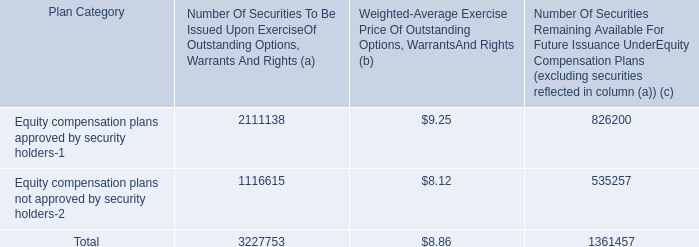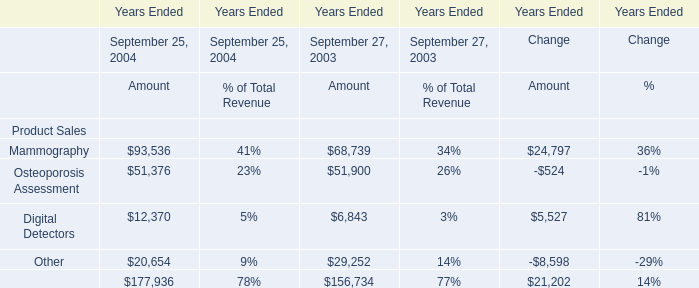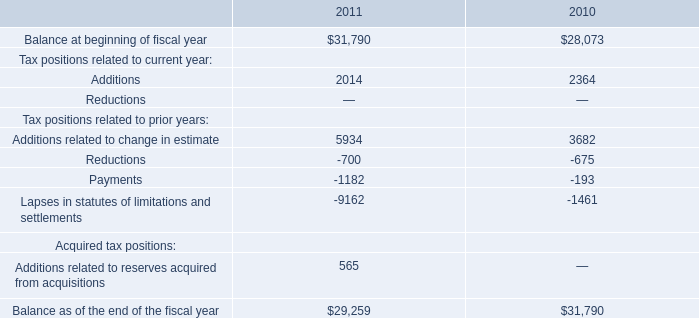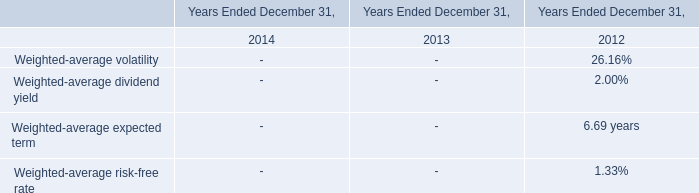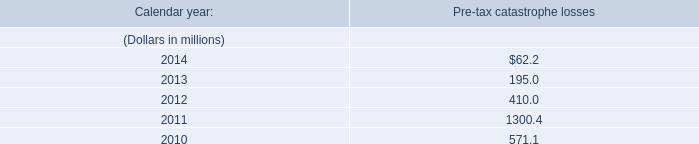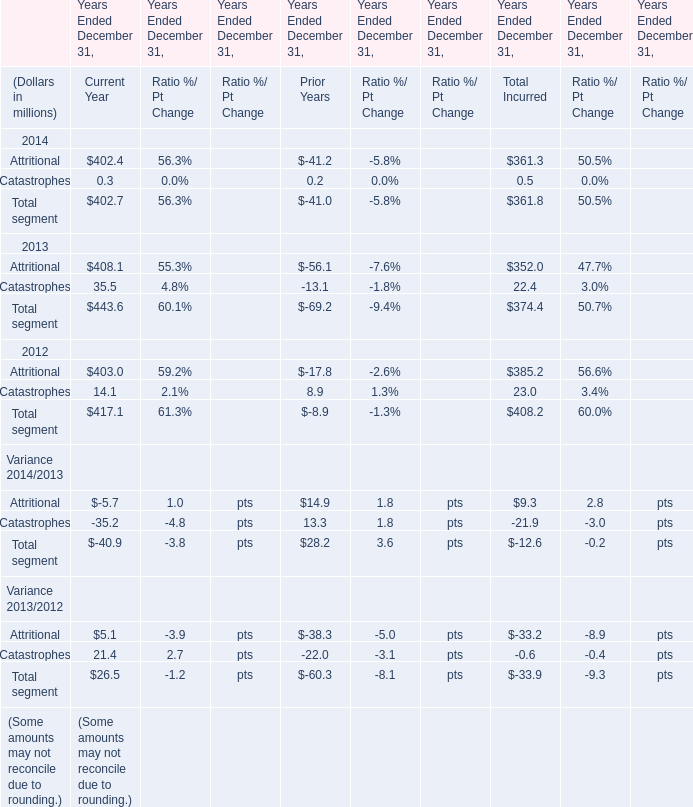How many element keeps increasing each year between 2004 and 2003 ? 
Answer: 4. 